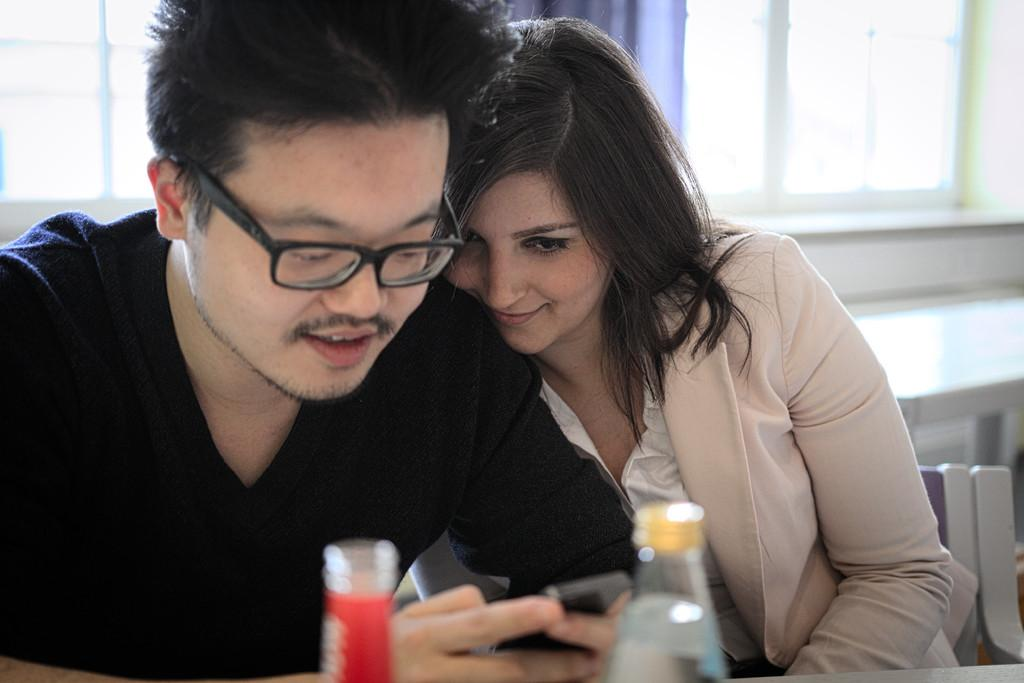How many people are sitting in the image? There are two persons sitting on chairs in the image. What is one person holding in the image? One person is holding a mobile in the image. What object can be seen besides the chairs and people? There is a bottle visible in the image. What can be seen in the background of the image? There is a window in the background of the image. What type of lettuce is being used as a tablecloth in the image? There is no lettuce present in the image, and it is not being used as a tablecloth. 